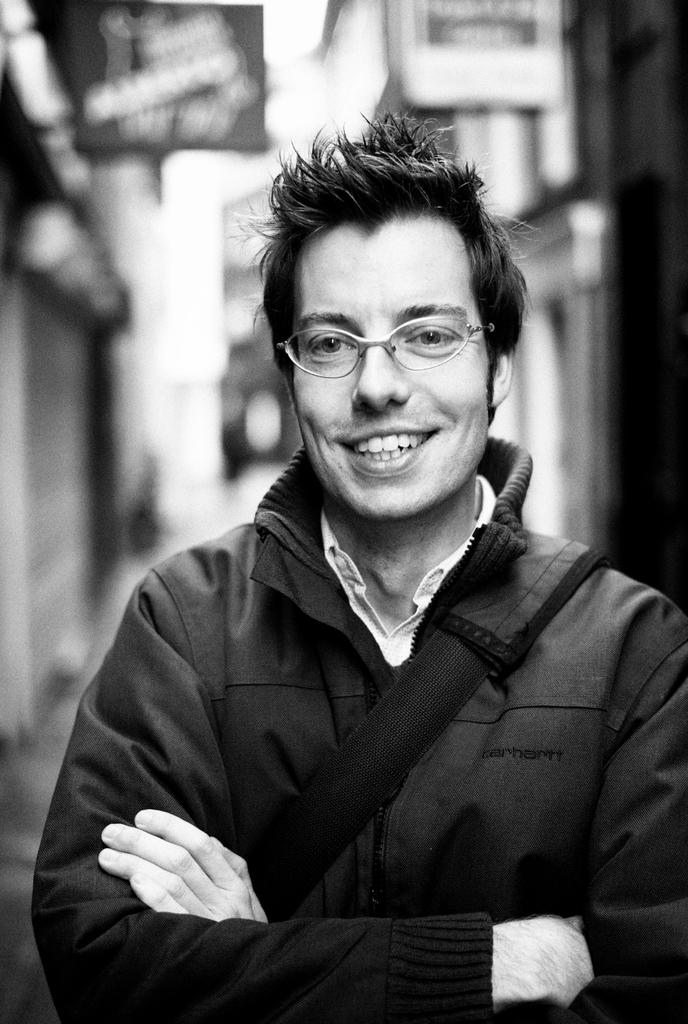Who is the main subject in the image? There is a man in the center of the image. What is the man doing in the image? The man is standing and smiling. Can you describe the background of the image? The background of the image is blurry. What type of hair is the horse wearing in the image? There is no horse present in the image, and therefore no hair to describe. 